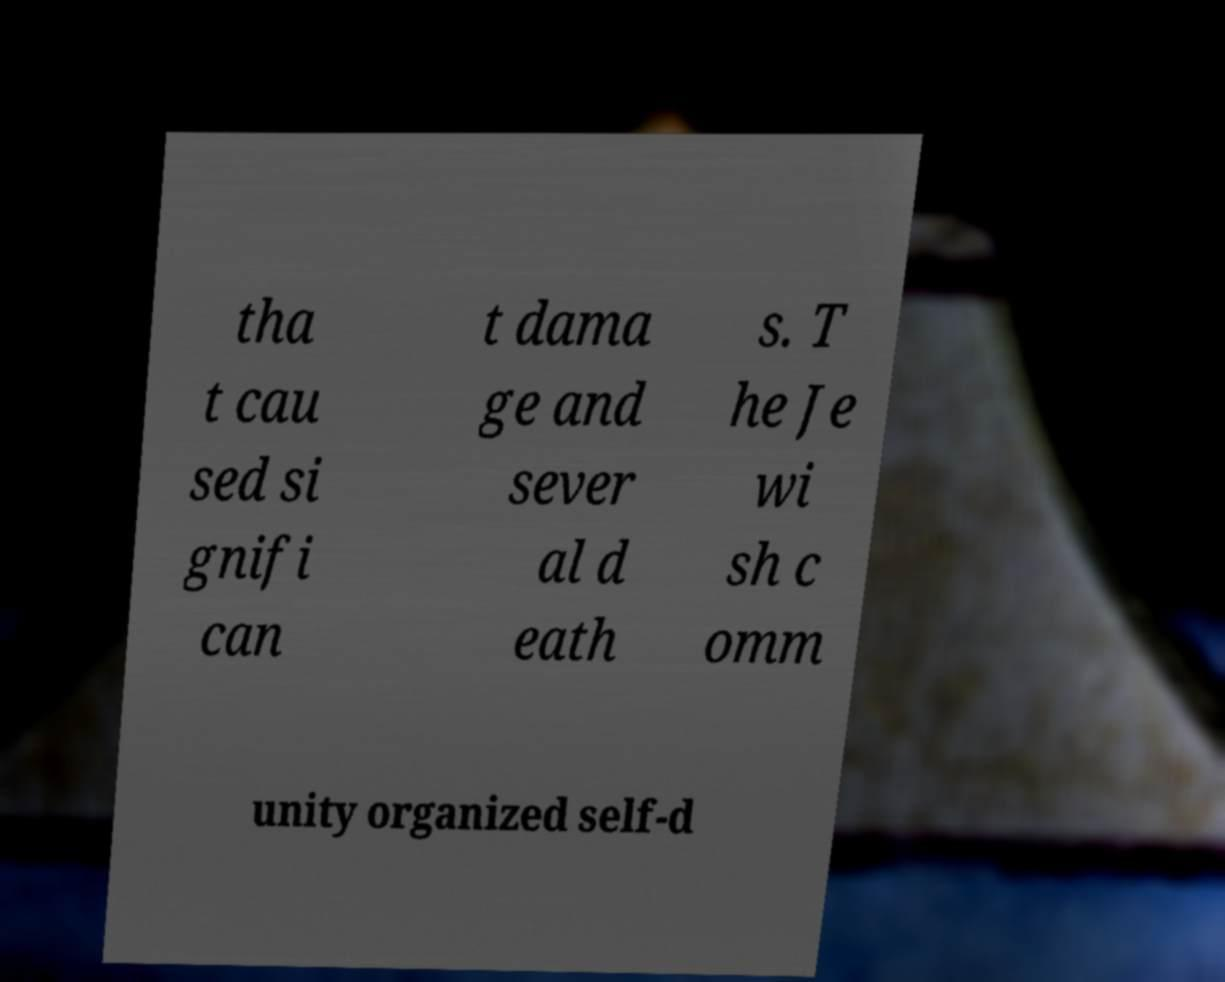Could you assist in decoding the text presented in this image and type it out clearly? tha t cau sed si gnifi can t dama ge and sever al d eath s. T he Je wi sh c omm unity organized self-d 